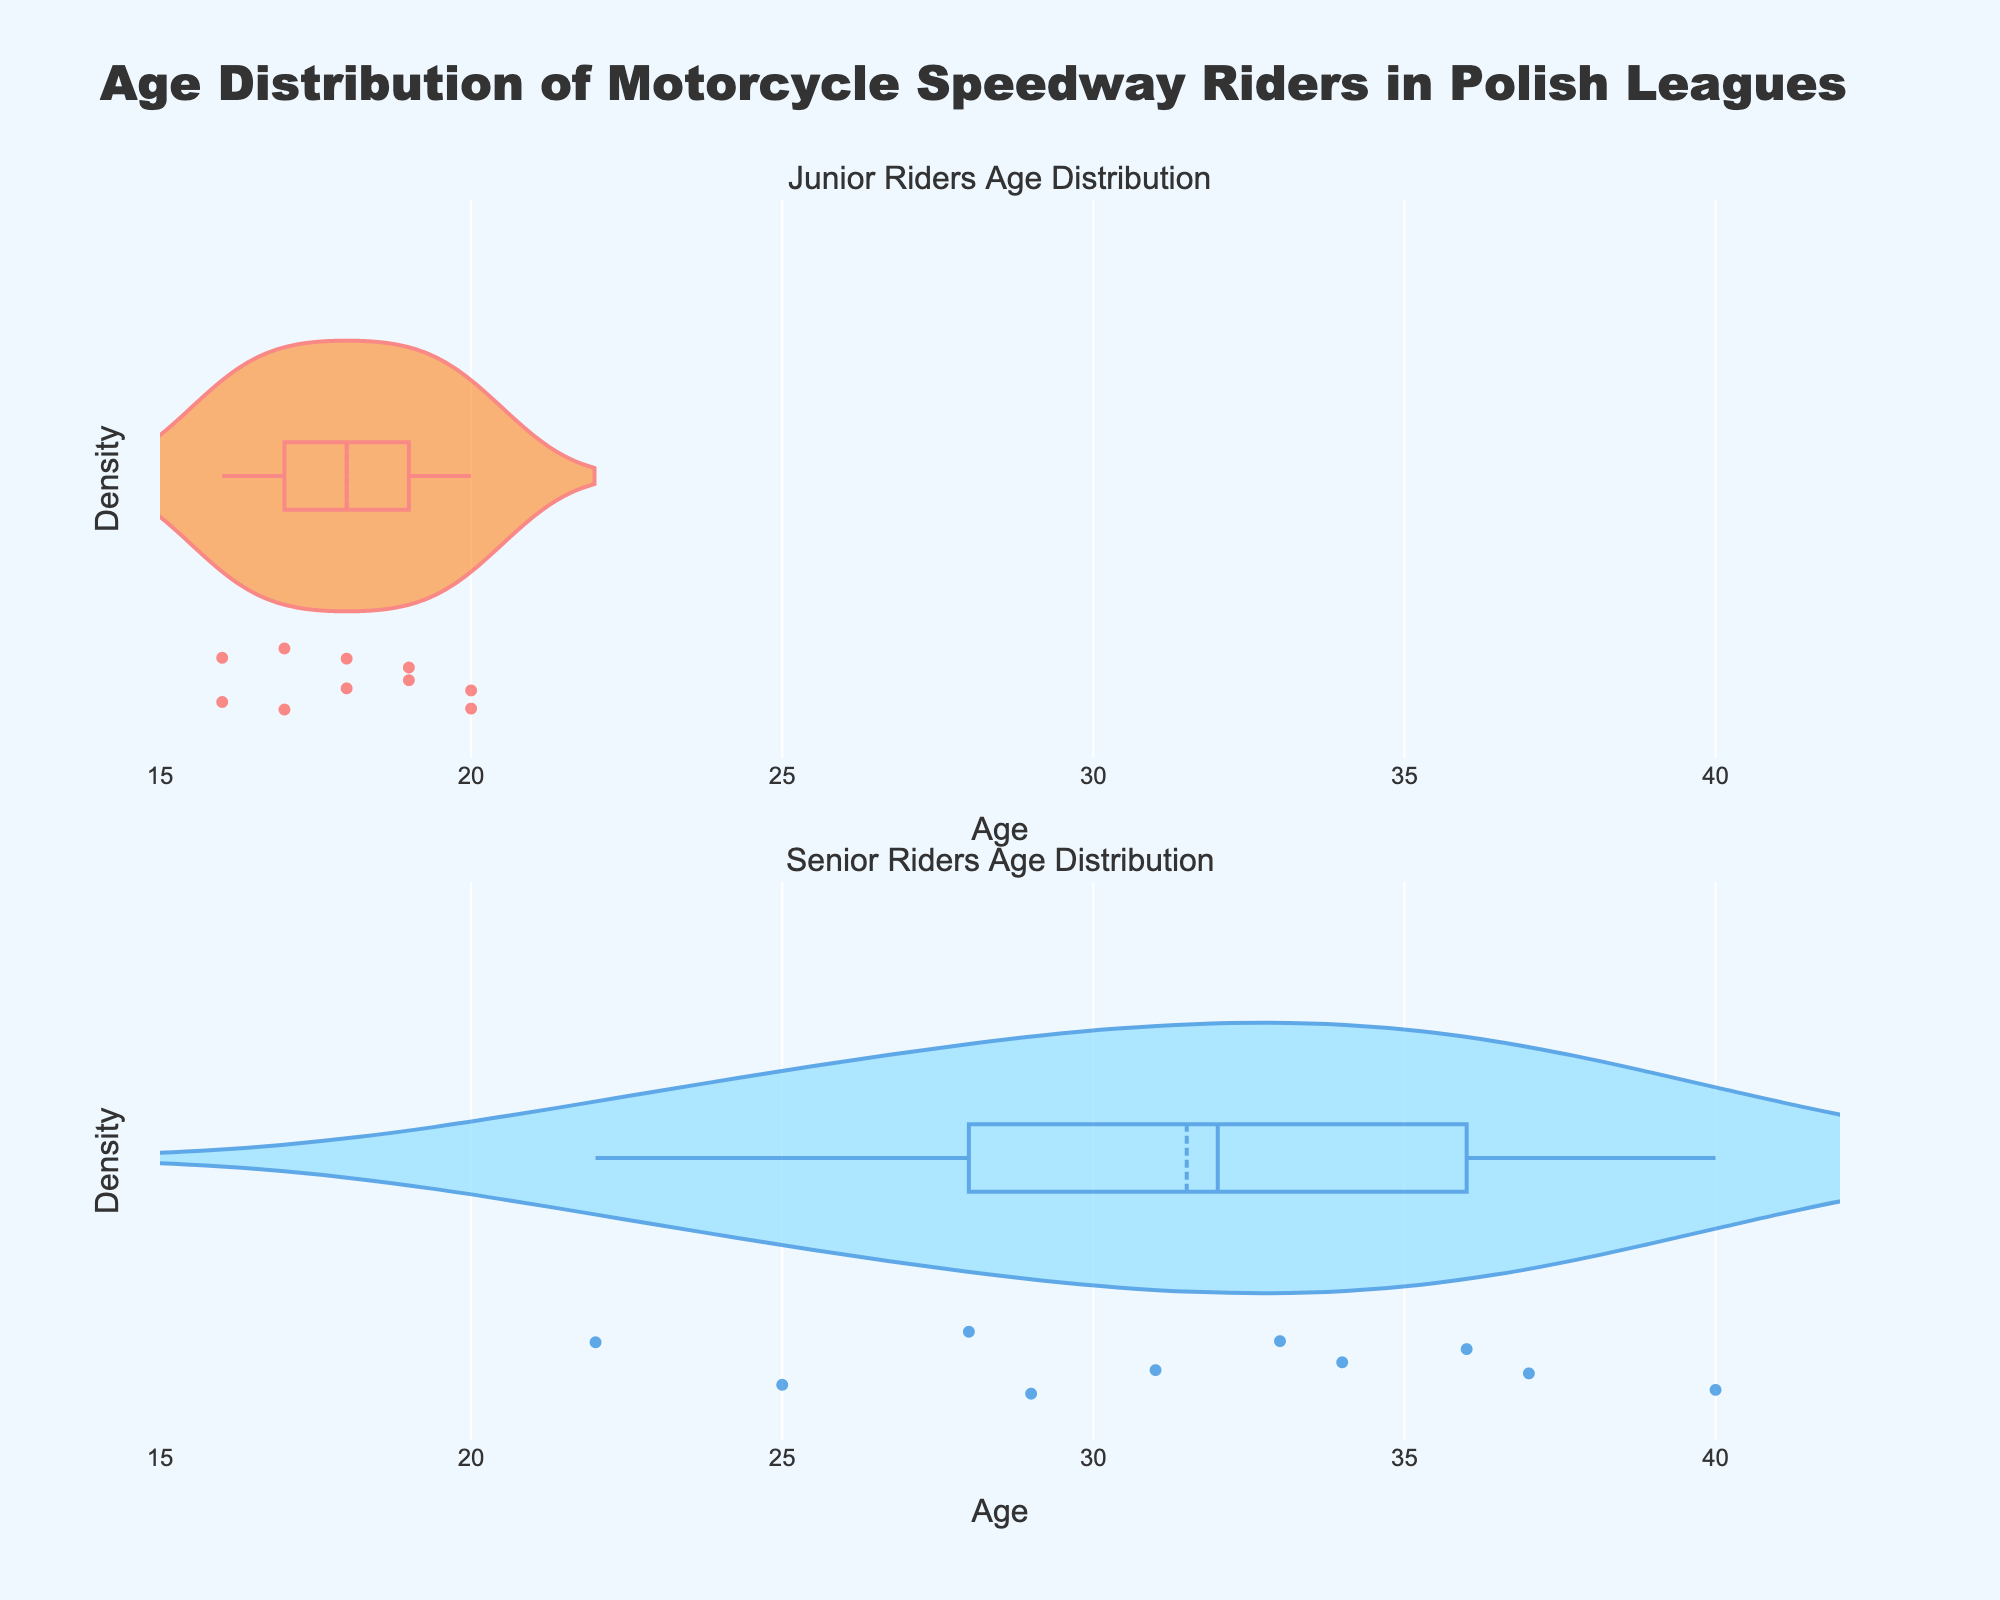What categories are being displayed in the density plots? The title and subplot titles indicate that the categories being displayed are "Junior Riders" and "Senior Riders".
Answer: Junior and Senior What is the range of ages displayed on the x-axis? The x-axis range is marked and described in the figure, ranging from 15 to 42.
Answer: 15 to 42 Which category, Junior or Senior, appears to have a wider age range? By observing the density plots, one can see that the Senior category spans from ages 22 to 40, while the Junior category spans from ages 16 to 20. Therefore, the Senior category has a wider age range.
Answer: Senior What is the peak age of Junior riders in the density plot? By looking at the density peak, the most frequent Junior rider age appears around 16-20 years.
Answer: Around 18 years How does the peak age of Senior riders compare to Junior riders? The peak in the Senior density plot appears around ages 28-31. Comparatively, this is higher than the peak for Junior riders around 18 years.
Answer: Higher Are the densities for Junior and Senior riders' ages evenly distributed across their respective ranges? The Junior density plot shows a more consistent distribution with slight peaks, while the Senior density plot has a more pronounced peak around ages 28-31. This indicates an uneven distribution for Seniors.
Answer: No Is there any overlap in the age range between Junior and Senior riders in the density plots? Observing the plots, there are distinct age ranges for both categories; Juniors range from 16-20, and Seniors from 22-40, with no overlap.
Answer: No What can be inferred about the mean line visible in the density plots for both categories? The mean line is observed in both plots and helps infer that Senior riders have a higher mean age compared to Junior riders.
Answer: Senior has a higher mean age Which category shows more variability in age, and how can you tell? The Senior density plot displays a wider spread and box plot than the Junior plot, indicating more variability in age for Senior riders.
Answer: Senior How do the violin plots visually communicate the data distributions of age in each rider category? Violin plots provide both a kernel density estimation and individual data points. The Junior plot is more evenly spread while the Senior plot shows a significant peak around ages 28-31, reflecting differing distributions.
Answer: By density peaks and spread 